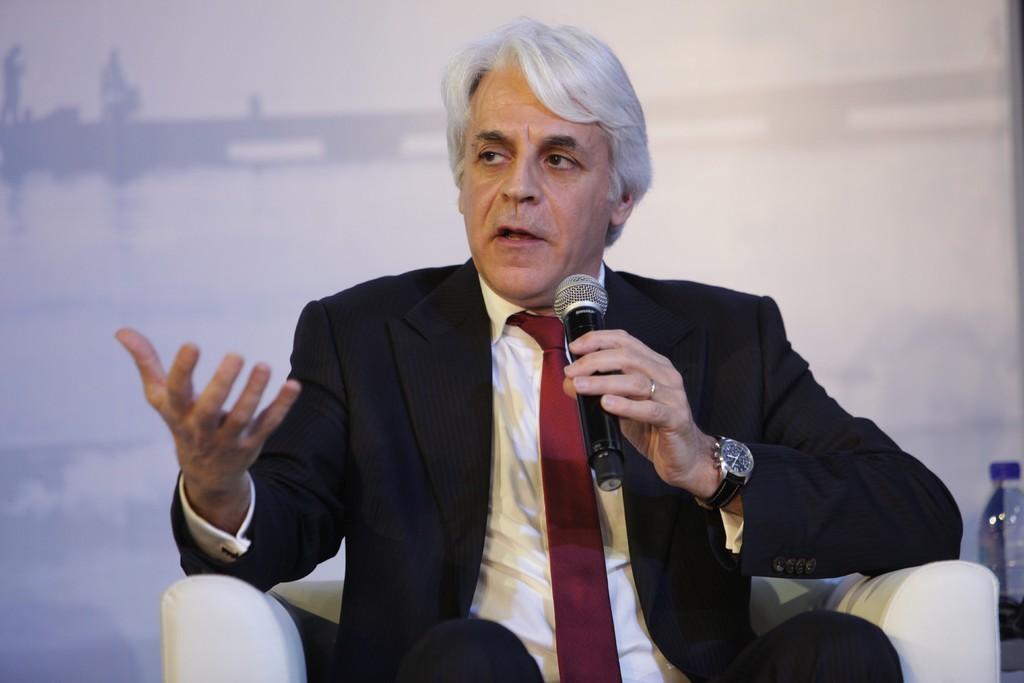Please provide a concise description of this image. The person wearing suit is sitting in a white sofa and speaking in front of a mic and the background is white in color. 